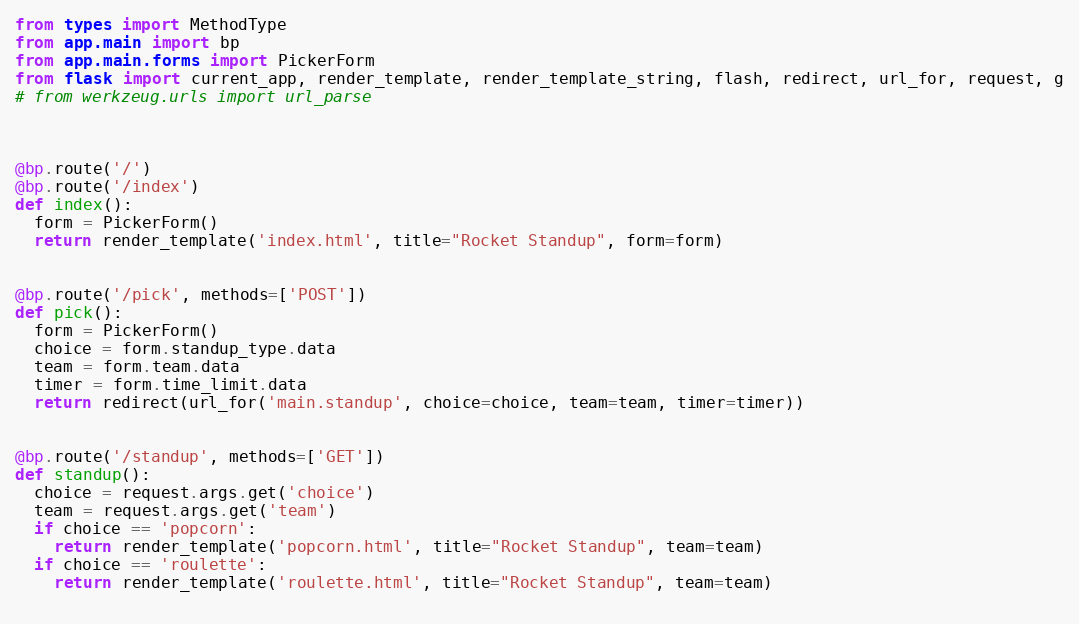Convert code to text. <code><loc_0><loc_0><loc_500><loc_500><_Python_>from types import MethodType
from app.main import bp
from app.main.forms import PickerForm
from flask import current_app, render_template, render_template_string, flash, redirect, url_for, request, g
# from werkzeug.urls import url_parse



@bp.route('/')
@bp.route('/index')
def index():
  form = PickerForm()
  return render_template('index.html', title="Rocket Standup", form=form)


@bp.route('/pick', methods=['POST'])
def pick():
  form = PickerForm()
  choice = form.standup_type.data
  team = form.team.data
  timer = form.time_limit.data
  return redirect(url_for('main.standup', choice=choice, team=team, timer=timer))


@bp.route('/standup', methods=['GET'])
def standup():
  choice = request.args.get('choice')
  team = request.args.get('team')
  if choice == 'popcorn':
    return render_template('popcorn.html', title="Rocket Standup", team=team)
  if choice == 'roulette':
    return render_template('roulette.html', title="Rocket Standup", team=team)
  

</code> 